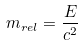<formula> <loc_0><loc_0><loc_500><loc_500>m _ { r e l } = \frac { E } { c ^ { 2 } }</formula> 